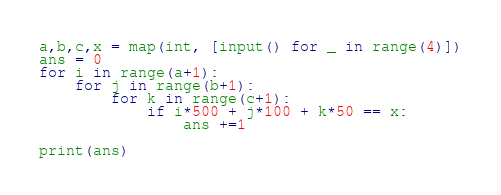Convert code to text. <code><loc_0><loc_0><loc_500><loc_500><_Python_>a,b,c,x = map(int, [input() for _ in range(4)])
ans = 0
for i in range(a+1):
    for j in range(b+1):
        for k in range(c+1):
            if i*500 + j*100 + k*50 == x:
                ans +=1

print(ans)
</code> 